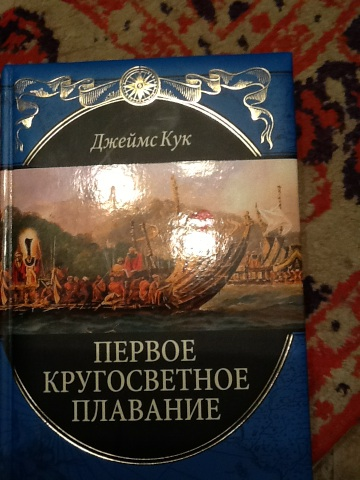If James Cook were to take his first voyage today, how different would it be? If James Cook embarked on his first voyage today, it would be vastly different due to modern technology and geopolitical changes. Satellites and GPS would replace the rudimentary maps and celestial navigation techniques of his time, allowing for precise mapping and navigation. Environmental conservation rules would guide his interactions with newly visited lands. Furthermore, the scientific knowledge he would need to gather would be more advanced, focusing perhaps on climate change impacts, deep-sea ecosystems, or even space observation from the clear skies of the open ocean. 